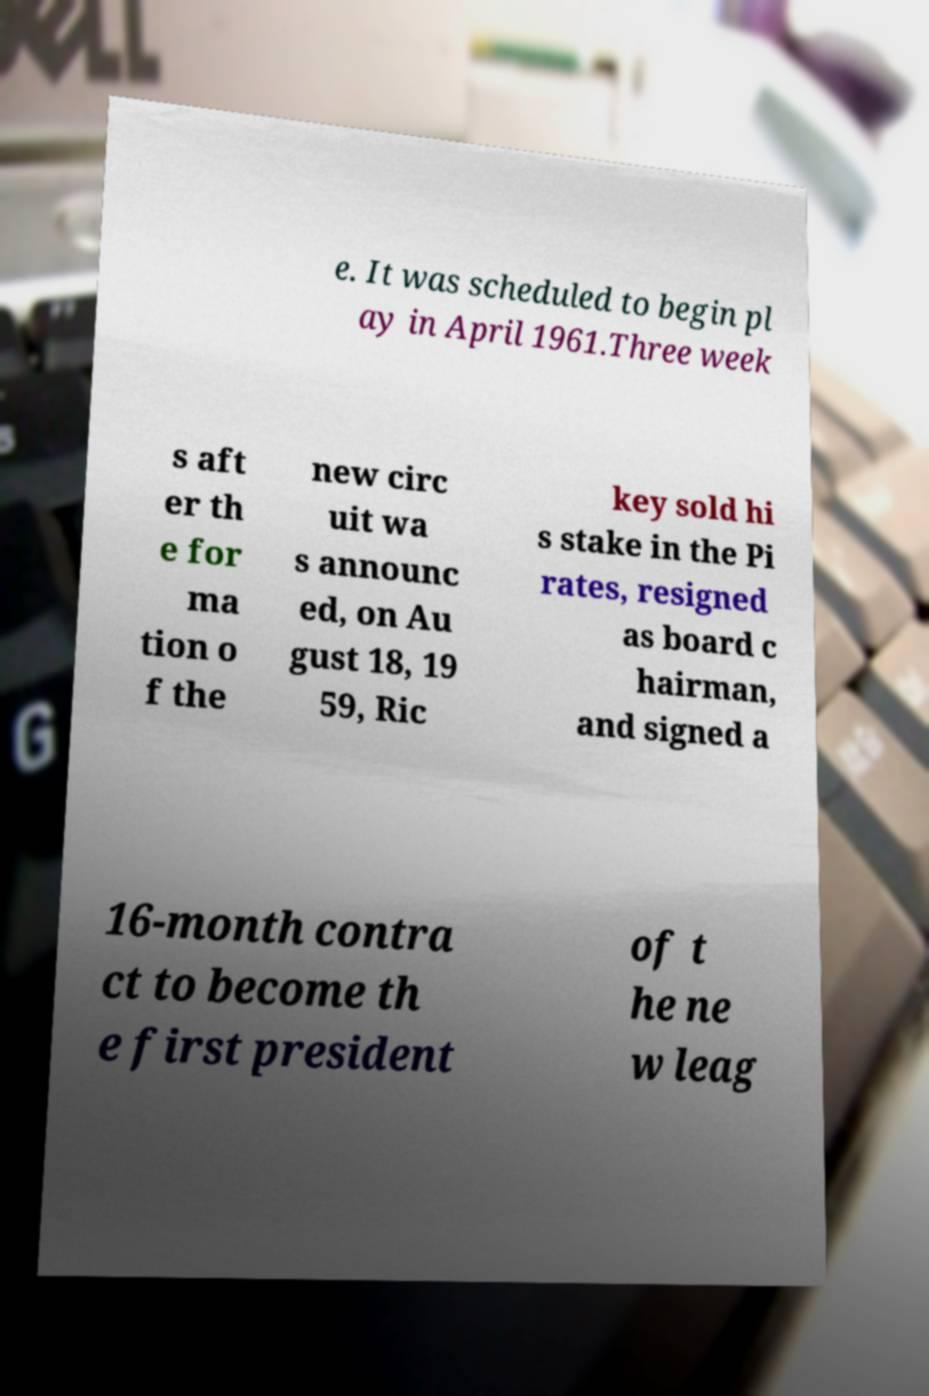Could you extract and type out the text from this image? e. It was scheduled to begin pl ay in April 1961.Three week s aft er th e for ma tion o f the new circ uit wa s announc ed, on Au gust 18, 19 59, Ric key sold hi s stake in the Pi rates, resigned as board c hairman, and signed a 16-month contra ct to become th e first president of t he ne w leag 